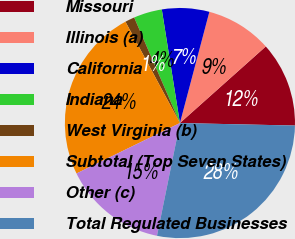Convert chart. <chart><loc_0><loc_0><loc_500><loc_500><pie_chart><fcel>Missouri<fcel>Illinois (a)<fcel>California<fcel>Indiana<fcel>West Virginia (b)<fcel>Subtotal (Top Seven States)<fcel>Other (c)<fcel>Total Regulated Businesses<nl><fcel>11.94%<fcel>9.29%<fcel>6.64%<fcel>3.99%<fcel>1.34%<fcel>24.37%<fcel>14.59%<fcel>27.85%<nl></chart> 